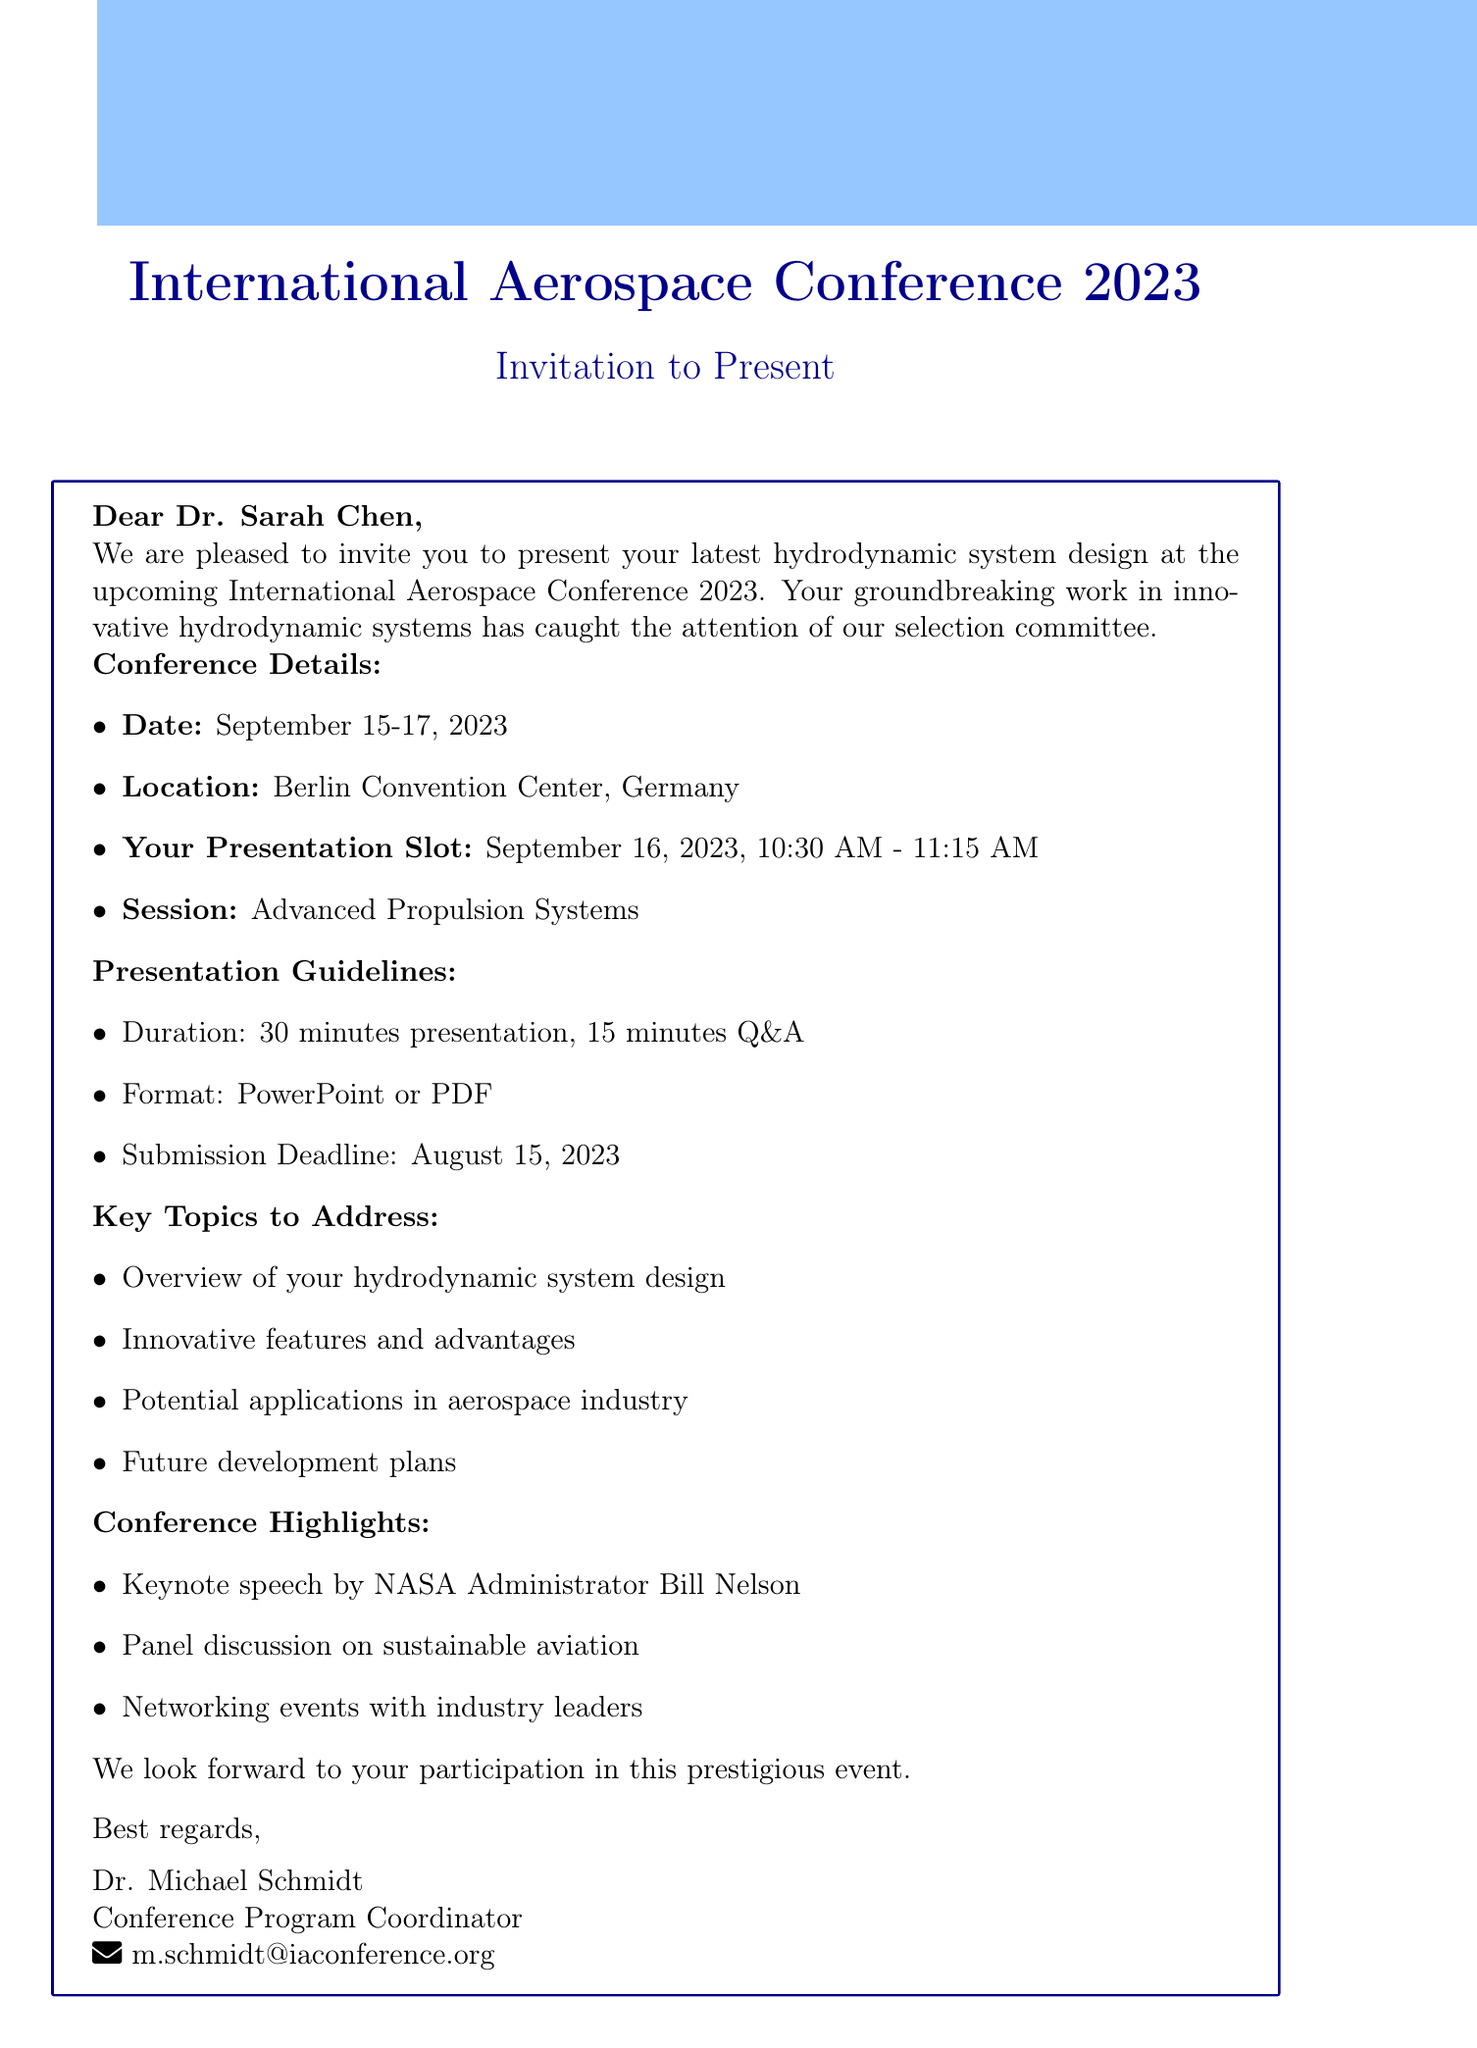What are the dates of the conference? The document states that the conference will take place from September 15-17, 2023.
Answer: September 15-17, 2023 Who is the recipient of the invitation? The invitation email is addressed to Dr. Sarah Chen.
Answer: Dr. Sarah Chen What is the presentation time slot? The document specifies that the presentation is scheduled for 10:30 AM to 11:15 AM on September 16, 2023.
Answer: 10:30 AM - 11:15 AM What format is acceptable for the presentation? The guidelines mention that the presentation can be in PowerPoint or PDF format.
Answer: PowerPoint or PDF What key topic addresses potential applications? The document lists "Potential applications in aerospace industry" as one of the key topics to address.
Answer: Potential applications in aerospace industry What is the submission deadline for the presentation? The email states that the submission deadline is August 15, 2023.
Answer: August 15, 2023 Who is the contact person for the conference? The document identifies Dr. Michael Schmidt as the contact person for the conference.
Answer: Dr. Michael Schmidt What are the highlights of the conference? "Keynote speech by NASA Administrator Bill Nelson" is one of the highlights mentioned in the document.
Answer: Keynote speech by NASA Administrator Bill Nelson How long is the Q&A session after the presentation? The guidelines indicate that there will be a 15-minute Q&A session following the presentation.
Answer: 15 minutes 